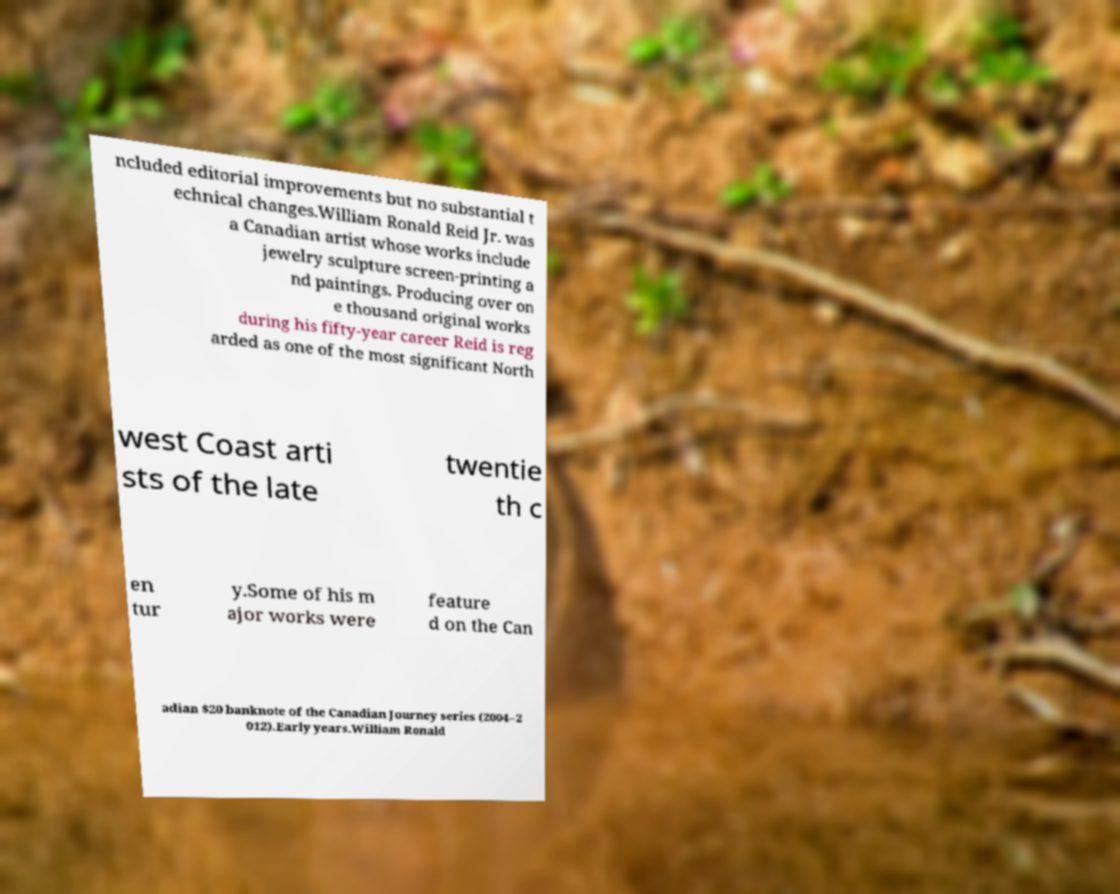Can you read and provide the text displayed in the image?This photo seems to have some interesting text. Can you extract and type it out for me? ncluded editorial improvements but no substantial t echnical changes.William Ronald Reid Jr. was a Canadian artist whose works include jewelry sculpture screen-printing a nd paintings. Producing over on e thousand original works during his fifty-year career Reid is reg arded as one of the most significant North west Coast arti sts of the late twentie th c en tur y.Some of his m ajor works were feature d on the Can adian $20 banknote of the Canadian Journey series (2004–2 012).Early years.William Ronald 